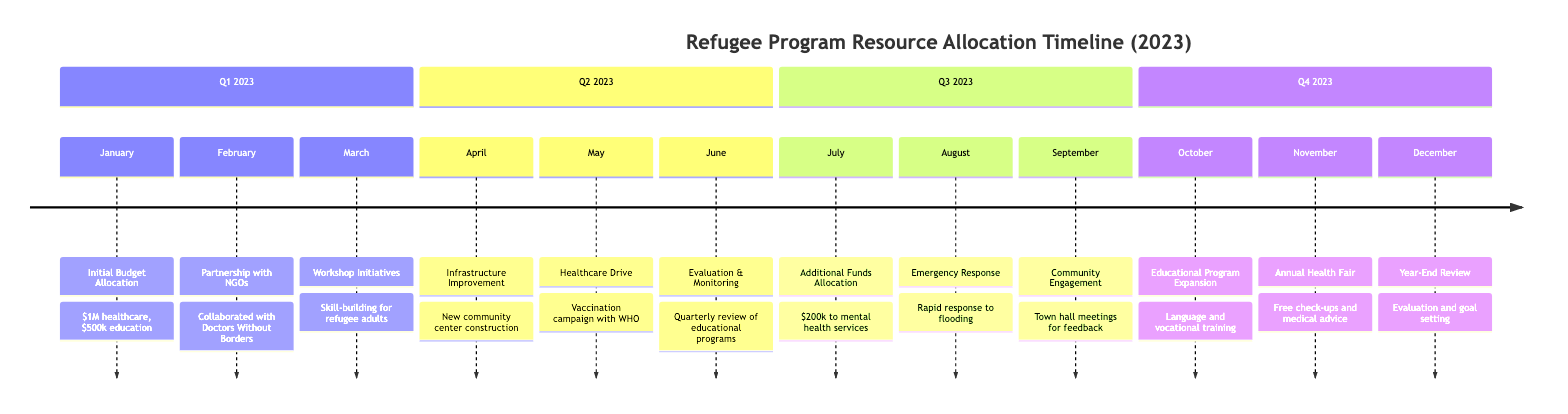What is the total budget allocation for healthcare in Q1 2023? In Q1 2023, the diagram states that $1 million was allocated for healthcare. This amount corresponds specifically to the January event labeled "Initial Budget Allocation."
Answer: $1 million How many events occurred in Q2 2023? The diagram lists three events for Q2 2023: "Infrastructure Improvement," "Healthcare Drive," and "Evaluation & Monitoring." Counting these gives a total of three events.
Answer: 3 What was the focus of the new classes initiated in October? The event in October 2023 states "Educational Program Expansion," emphasizing new classes in language acquisition and vocational training. This indicates the educational focus of the initiative.
Answer: Language acquisition and vocational training Which NGO partnered in February for resource allocation? The February event mentions a partnership with "Doctors Without Borders" for medical supplies, specifically highlighting this organization as the partner involved in resource allocation relevant to healthcare.
Answer: Doctors Without Borders What was the main reason for the additional funds allocation in July? The event in July indicates that $200k was redirected to mental health services, based on "community feedback." This reasoning showcases how community input influenced financial decisions for resources.
Answer: Community feedback What significant health initiative was organized in May? The event in May describes a "Healthcare Drive," detailing a vaccination campaign organized in collaboration with WHO. This indicates a significant health initiative aimed at increasing vaccination rates.
Answer: Vaccination campaign How did the local government respond to the flooding in August? The August event outlines the deployment of a "rapid response team" to address the flooding in Refugee Camp A. This demonstrates a proactive approach in emergency management and support for affected refugees.
Answer: Rapid response team What was evaluated in June regarding the educational programs? The June event focuses on an "Evaluation & Monitoring" that involved a quarterly review of educational programs' impact, showcasing accountability and assessment of resources allocated to education.
Answer: Educational programs’ impact What event signifies the end of the year review for resource allocation? The December event is labeled "Year-End Review," which indicates that this event represents the evaluation and setting of future goals for resource allocation in the context of refugee programs.
Answer: Year-End Review 